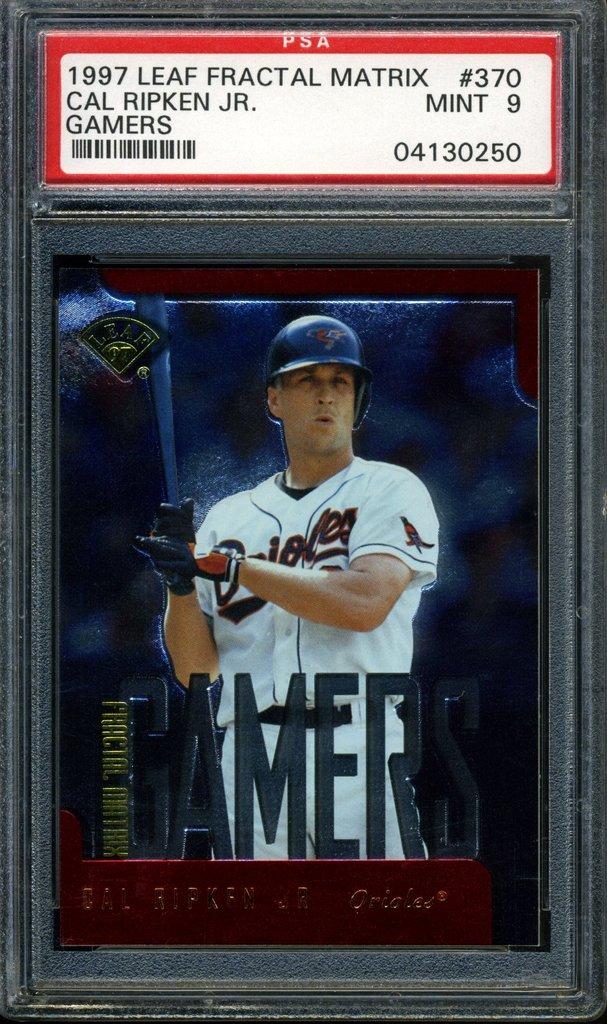What year is the baseball card for cal ripken jr.?
Provide a short and direct response. 1997. Who is the baseball player on the card?
Your answer should be compact. Cal ripken jr. 